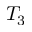Convert formula to latex. <formula><loc_0><loc_0><loc_500><loc_500>T _ { 3 }</formula> 